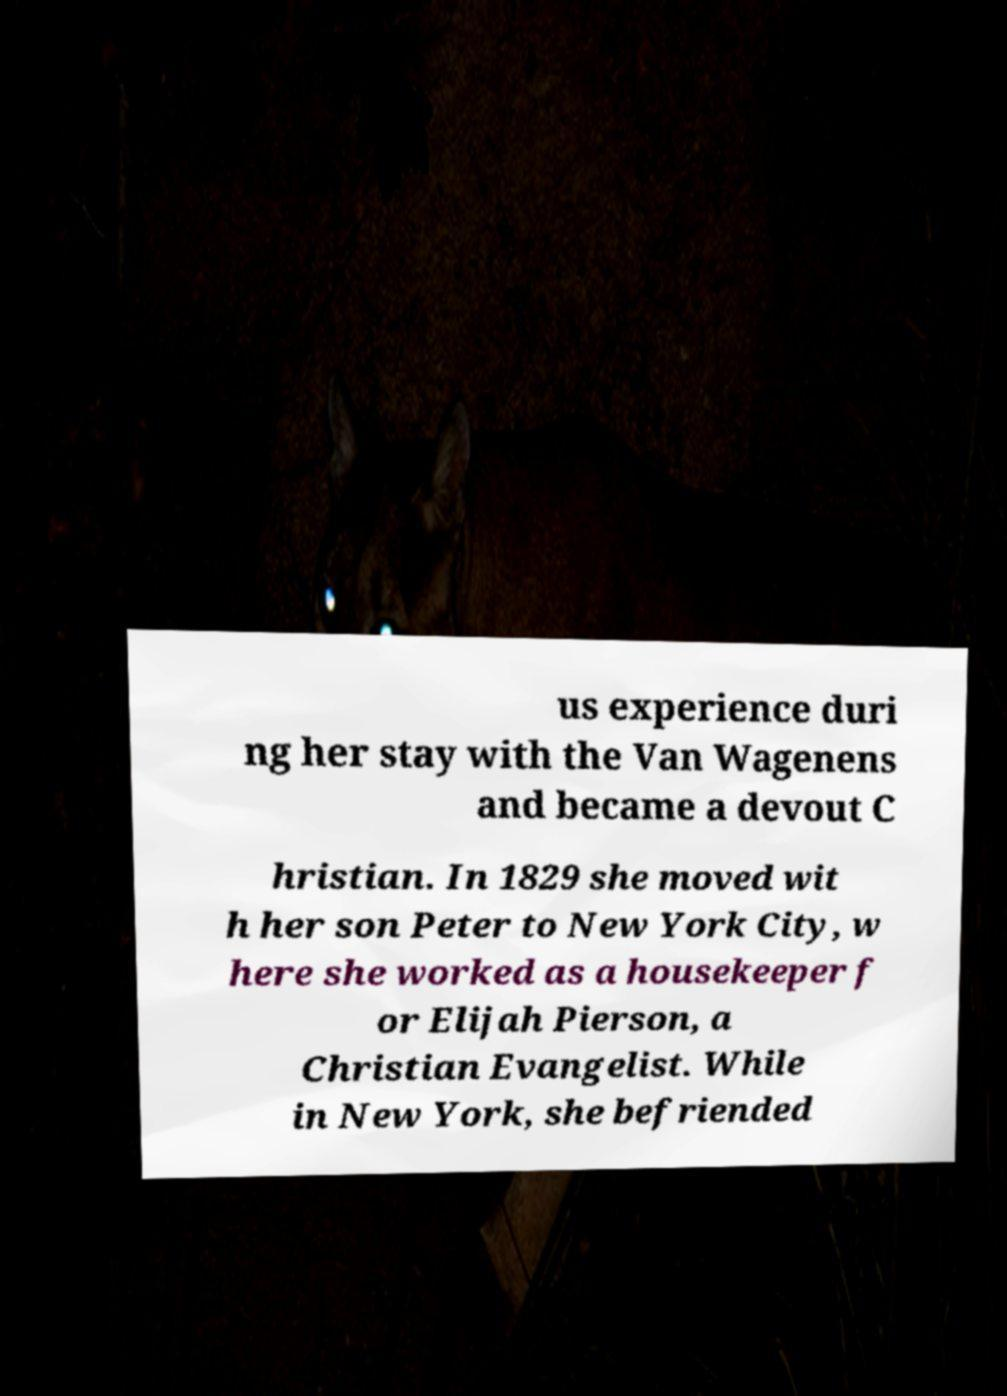Please identify and transcribe the text found in this image. us experience duri ng her stay with the Van Wagenens and became a devout C hristian. In 1829 she moved wit h her son Peter to New York City, w here she worked as a housekeeper f or Elijah Pierson, a Christian Evangelist. While in New York, she befriended 